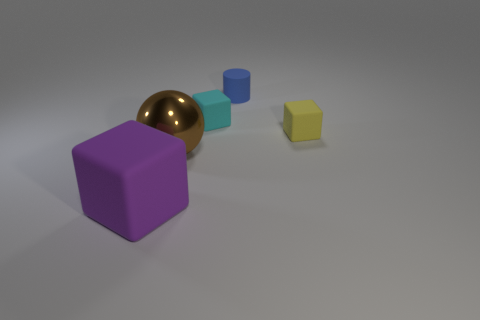How would you describe the composition of the objects in terms of colors and shapes? The composition consists of four geometric shapes. Starting from the left, there's a large purple cube, next to a slightly shiny, reflective gold sphere, followed by a smaller cyan cube, and lastly a tiny yellow cube. The arrangement displays a descending order in size and a variety of colors enhancing visual contrast. 